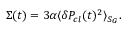<formula> <loc_0><loc_0><loc_500><loc_500>\Sigma ( t ) = 3 \alpha \langle \delta P _ { c l } ( t ) ^ { 2 } \rangle _ { S _ { G } } .</formula> 